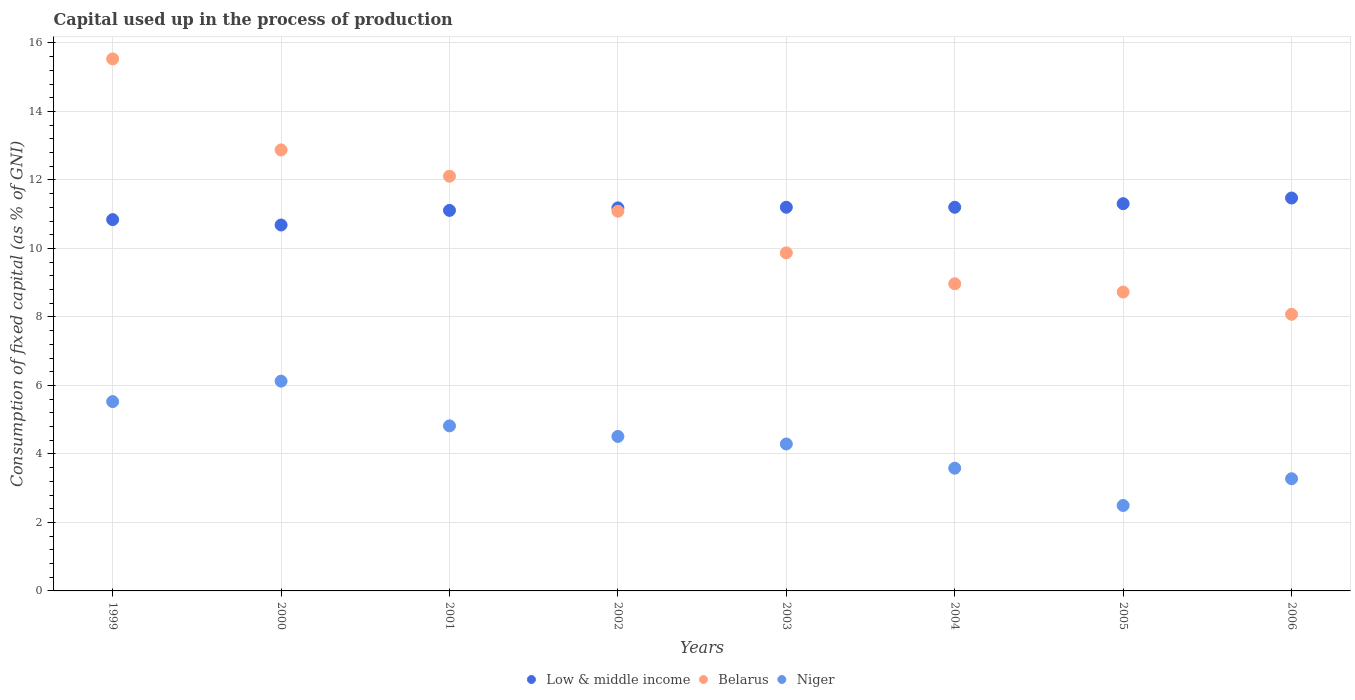What is the capital used up in the process of production in Belarus in 2005?
Your answer should be very brief. 8.73. Across all years, what is the maximum capital used up in the process of production in Niger?
Provide a succinct answer. 6.13. Across all years, what is the minimum capital used up in the process of production in Belarus?
Offer a terse response. 8.08. In which year was the capital used up in the process of production in Low & middle income maximum?
Offer a terse response. 2006. In which year was the capital used up in the process of production in Low & middle income minimum?
Provide a succinct answer. 2000. What is the total capital used up in the process of production in Low & middle income in the graph?
Your answer should be very brief. 89. What is the difference between the capital used up in the process of production in Belarus in 1999 and that in 2003?
Your answer should be compact. 5.66. What is the difference between the capital used up in the process of production in Low & middle income in 2003 and the capital used up in the process of production in Niger in 2005?
Provide a succinct answer. 8.71. What is the average capital used up in the process of production in Low & middle income per year?
Offer a terse response. 11.13. In the year 2003, what is the difference between the capital used up in the process of production in Belarus and capital used up in the process of production in Low & middle income?
Keep it short and to the point. -1.33. In how many years, is the capital used up in the process of production in Low & middle income greater than 12 %?
Ensure brevity in your answer.  0. What is the ratio of the capital used up in the process of production in Low & middle income in 1999 to that in 2005?
Provide a short and direct response. 0.96. Is the capital used up in the process of production in Low & middle income in 2003 less than that in 2006?
Give a very brief answer. Yes. What is the difference between the highest and the second highest capital used up in the process of production in Low & middle income?
Give a very brief answer. 0.17. What is the difference between the highest and the lowest capital used up in the process of production in Low & middle income?
Offer a terse response. 0.79. Is it the case that in every year, the sum of the capital used up in the process of production in Belarus and capital used up in the process of production in Niger  is greater than the capital used up in the process of production in Low & middle income?
Your response must be concise. No. Is the capital used up in the process of production in Niger strictly less than the capital used up in the process of production in Belarus over the years?
Give a very brief answer. Yes. How many years are there in the graph?
Ensure brevity in your answer.  8. What is the difference between two consecutive major ticks on the Y-axis?
Your response must be concise. 2. Are the values on the major ticks of Y-axis written in scientific E-notation?
Make the answer very short. No. Does the graph contain any zero values?
Provide a succinct answer. No. What is the title of the graph?
Your answer should be very brief. Capital used up in the process of production. What is the label or title of the Y-axis?
Offer a very short reply. Consumption of fixed capital (as % of GNI). What is the Consumption of fixed capital (as % of GNI) of Low & middle income in 1999?
Your answer should be very brief. 10.84. What is the Consumption of fixed capital (as % of GNI) of Belarus in 1999?
Offer a terse response. 15.53. What is the Consumption of fixed capital (as % of GNI) in Niger in 1999?
Offer a terse response. 5.53. What is the Consumption of fixed capital (as % of GNI) of Low & middle income in 2000?
Offer a very short reply. 10.68. What is the Consumption of fixed capital (as % of GNI) of Belarus in 2000?
Your response must be concise. 12.88. What is the Consumption of fixed capital (as % of GNI) in Niger in 2000?
Your answer should be compact. 6.13. What is the Consumption of fixed capital (as % of GNI) of Low & middle income in 2001?
Give a very brief answer. 11.11. What is the Consumption of fixed capital (as % of GNI) of Belarus in 2001?
Give a very brief answer. 12.11. What is the Consumption of fixed capital (as % of GNI) in Niger in 2001?
Your response must be concise. 4.82. What is the Consumption of fixed capital (as % of GNI) in Low & middle income in 2002?
Ensure brevity in your answer.  11.18. What is the Consumption of fixed capital (as % of GNI) in Belarus in 2002?
Your response must be concise. 11.09. What is the Consumption of fixed capital (as % of GNI) in Niger in 2002?
Provide a short and direct response. 4.51. What is the Consumption of fixed capital (as % of GNI) in Low & middle income in 2003?
Give a very brief answer. 11.2. What is the Consumption of fixed capital (as % of GNI) of Belarus in 2003?
Give a very brief answer. 9.87. What is the Consumption of fixed capital (as % of GNI) in Niger in 2003?
Provide a short and direct response. 4.29. What is the Consumption of fixed capital (as % of GNI) in Low & middle income in 2004?
Your answer should be very brief. 11.2. What is the Consumption of fixed capital (as % of GNI) of Belarus in 2004?
Make the answer very short. 8.97. What is the Consumption of fixed capital (as % of GNI) of Niger in 2004?
Keep it short and to the point. 3.58. What is the Consumption of fixed capital (as % of GNI) of Low & middle income in 2005?
Offer a very short reply. 11.31. What is the Consumption of fixed capital (as % of GNI) of Belarus in 2005?
Give a very brief answer. 8.73. What is the Consumption of fixed capital (as % of GNI) in Niger in 2005?
Offer a terse response. 2.49. What is the Consumption of fixed capital (as % of GNI) in Low & middle income in 2006?
Offer a terse response. 11.47. What is the Consumption of fixed capital (as % of GNI) of Belarus in 2006?
Offer a terse response. 8.08. What is the Consumption of fixed capital (as % of GNI) of Niger in 2006?
Ensure brevity in your answer.  3.28. Across all years, what is the maximum Consumption of fixed capital (as % of GNI) in Low & middle income?
Offer a terse response. 11.47. Across all years, what is the maximum Consumption of fixed capital (as % of GNI) in Belarus?
Your answer should be compact. 15.53. Across all years, what is the maximum Consumption of fixed capital (as % of GNI) of Niger?
Offer a terse response. 6.13. Across all years, what is the minimum Consumption of fixed capital (as % of GNI) of Low & middle income?
Your response must be concise. 10.68. Across all years, what is the minimum Consumption of fixed capital (as % of GNI) of Belarus?
Your response must be concise. 8.08. Across all years, what is the minimum Consumption of fixed capital (as % of GNI) of Niger?
Your response must be concise. 2.49. What is the total Consumption of fixed capital (as % of GNI) of Low & middle income in the graph?
Provide a succinct answer. 89. What is the total Consumption of fixed capital (as % of GNI) in Belarus in the graph?
Give a very brief answer. 87.25. What is the total Consumption of fixed capital (as % of GNI) of Niger in the graph?
Keep it short and to the point. 34.63. What is the difference between the Consumption of fixed capital (as % of GNI) in Low & middle income in 1999 and that in 2000?
Your response must be concise. 0.16. What is the difference between the Consumption of fixed capital (as % of GNI) in Belarus in 1999 and that in 2000?
Keep it short and to the point. 2.66. What is the difference between the Consumption of fixed capital (as % of GNI) of Niger in 1999 and that in 2000?
Offer a very short reply. -0.6. What is the difference between the Consumption of fixed capital (as % of GNI) of Low & middle income in 1999 and that in 2001?
Offer a very short reply. -0.27. What is the difference between the Consumption of fixed capital (as % of GNI) in Belarus in 1999 and that in 2001?
Keep it short and to the point. 3.42. What is the difference between the Consumption of fixed capital (as % of GNI) in Niger in 1999 and that in 2001?
Keep it short and to the point. 0.71. What is the difference between the Consumption of fixed capital (as % of GNI) in Low & middle income in 1999 and that in 2002?
Offer a terse response. -0.34. What is the difference between the Consumption of fixed capital (as % of GNI) of Belarus in 1999 and that in 2002?
Offer a terse response. 4.45. What is the difference between the Consumption of fixed capital (as % of GNI) of Niger in 1999 and that in 2002?
Ensure brevity in your answer.  1.02. What is the difference between the Consumption of fixed capital (as % of GNI) of Low & middle income in 1999 and that in 2003?
Offer a very short reply. -0.36. What is the difference between the Consumption of fixed capital (as % of GNI) in Belarus in 1999 and that in 2003?
Give a very brief answer. 5.66. What is the difference between the Consumption of fixed capital (as % of GNI) in Niger in 1999 and that in 2003?
Offer a very short reply. 1.24. What is the difference between the Consumption of fixed capital (as % of GNI) in Low & middle income in 1999 and that in 2004?
Keep it short and to the point. -0.36. What is the difference between the Consumption of fixed capital (as % of GNI) of Belarus in 1999 and that in 2004?
Ensure brevity in your answer.  6.57. What is the difference between the Consumption of fixed capital (as % of GNI) in Niger in 1999 and that in 2004?
Provide a short and direct response. 1.94. What is the difference between the Consumption of fixed capital (as % of GNI) of Low & middle income in 1999 and that in 2005?
Your answer should be compact. -0.47. What is the difference between the Consumption of fixed capital (as % of GNI) of Belarus in 1999 and that in 2005?
Provide a short and direct response. 6.81. What is the difference between the Consumption of fixed capital (as % of GNI) of Niger in 1999 and that in 2005?
Offer a very short reply. 3.03. What is the difference between the Consumption of fixed capital (as % of GNI) in Low & middle income in 1999 and that in 2006?
Offer a very short reply. -0.63. What is the difference between the Consumption of fixed capital (as % of GNI) in Belarus in 1999 and that in 2006?
Your answer should be compact. 7.46. What is the difference between the Consumption of fixed capital (as % of GNI) in Niger in 1999 and that in 2006?
Offer a terse response. 2.25. What is the difference between the Consumption of fixed capital (as % of GNI) of Low & middle income in 2000 and that in 2001?
Offer a very short reply. -0.43. What is the difference between the Consumption of fixed capital (as % of GNI) in Belarus in 2000 and that in 2001?
Provide a short and direct response. 0.77. What is the difference between the Consumption of fixed capital (as % of GNI) of Niger in 2000 and that in 2001?
Offer a terse response. 1.31. What is the difference between the Consumption of fixed capital (as % of GNI) of Low & middle income in 2000 and that in 2002?
Offer a terse response. -0.5. What is the difference between the Consumption of fixed capital (as % of GNI) in Belarus in 2000 and that in 2002?
Ensure brevity in your answer.  1.79. What is the difference between the Consumption of fixed capital (as % of GNI) in Niger in 2000 and that in 2002?
Your answer should be compact. 1.61. What is the difference between the Consumption of fixed capital (as % of GNI) of Low & middle income in 2000 and that in 2003?
Provide a short and direct response. -0.52. What is the difference between the Consumption of fixed capital (as % of GNI) of Belarus in 2000 and that in 2003?
Offer a terse response. 3.01. What is the difference between the Consumption of fixed capital (as % of GNI) in Niger in 2000 and that in 2003?
Offer a very short reply. 1.83. What is the difference between the Consumption of fixed capital (as % of GNI) in Low & middle income in 2000 and that in 2004?
Ensure brevity in your answer.  -0.52. What is the difference between the Consumption of fixed capital (as % of GNI) of Belarus in 2000 and that in 2004?
Your answer should be compact. 3.91. What is the difference between the Consumption of fixed capital (as % of GNI) of Niger in 2000 and that in 2004?
Keep it short and to the point. 2.54. What is the difference between the Consumption of fixed capital (as % of GNI) of Low & middle income in 2000 and that in 2005?
Keep it short and to the point. -0.62. What is the difference between the Consumption of fixed capital (as % of GNI) in Belarus in 2000 and that in 2005?
Offer a terse response. 4.15. What is the difference between the Consumption of fixed capital (as % of GNI) in Niger in 2000 and that in 2005?
Provide a short and direct response. 3.63. What is the difference between the Consumption of fixed capital (as % of GNI) of Low & middle income in 2000 and that in 2006?
Keep it short and to the point. -0.79. What is the difference between the Consumption of fixed capital (as % of GNI) in Belarus in 2000 and that in 2006?
Provide a short and direct response. 4.8. What is the difference between the Consumption of fixed capital (as % of GNI) in Niger in 2000 and that in 2006?
Offer a very short reply. 2.85. What is the difference between the Consumption of fixed capital (as % of GNI) in Low & middle income in 2001 and that in 2002?
Your answer should be compact. -0.07. What is the difference between the Consumption of fixed capital (as % of GNI) of Belarus in 2001 and that in 2002?
Your answer should be compact. 1.02. What is the difference between the Consumption of fixed capital (as % of GNI) of Niger in 2001 and that in 2002?
Keep it short and to the point. 0.31. What is the difference between the Consumption of fixed capital (as % of GNI) in Low & middle income in 2001 and that in 2003?
Your answer should be very brief. -0.09. What is the difference between the Consumption of fixed capital (as % of GNI) in Belarus in 2001 and that in 2003?
Offer a very short reply. 2.24. What is the difference between the Consumption of fixed capital (as % of GNI) in Niger in 2001 and that in 2003?
Your answer should be compact. 0.53. What is the difference between the Consumption of fixed capital (as % of GNI) of Low & middle income in 2001 and that in 2004?
Your response must be concise. -0.09. What is the difference between the Consumption of fixed capital (as % of GNI) of Belarus in 2001 and that in 2004?
Your answer should be compact. 3.14. What is the difference between the Consumption of fixed capital (as % of GNI) of Niger in 2001 and that in 2004?
Provide a short and direct response. 1.24. What is the difference between the Consumption of fixed capital (as % of GNI) in Low & middle income in 2001 and that in 2005?
Offer a very short reply. -0.2. What is the difference between the Consumption of fixed capital (as % of GNI) in Belarus in 2001 and that in 2005?
Provide a short and direct response. 3.38. What is the difference between the Consumption of fixed capital (as % of GNI) of Niger in 2001 and that in 2005?
Keep it short and to the point. 2.32. What is the difference between the Consumption of fixed capital (as % of GNI) of Low & middle income in 2001 and that in 2006?
Your response must be concise. -0.36. What is the difference between the Consumption of fixed capital (as % of GNI) in Belarus in 2001 and that in 2006?
Provide a succinct answer. 4.03. What is the difference between the Consumption of fixed capital (as % of GNI) of Niger in 2001 and that in 2006?
Offer a very short reply. 1.54. What is the difference between the Consumption of fixed capital (as % of GNI) in Low & middle income in 2002 and that in 2003?
Your response must be concise. -0.02. What is the difference between the Consumption of fixed capital (as % of GNI) of Belarus in 2002 and that in 2003?
Give a very brief answer. 1.22. What is the difference between the Consumption of fixed capital (as % of GNI) in Niger in 2002 and that in 2003?
Provide a succinct answer. 0.22. What is the difference between the Consumption of fixed capital (as % of GNI) in Low & middle income in 2002 and that in 2004?
Ensure brevity in your answer.  -0.02. What is the difference between the Consumption of fixed capital (as % of GNI) in Belarus in 2002 and that in 2004?
Give a very brief answer. 2.12. What is the difference between the Consumption of fixed capital (as % of GNI) in Niger in 2002 and that in 2004?
Keep it short and to the point. 0.93. What is the difference between the Consumption of fixed capital (as % of GNI) in Low & middle income in 2002 and that in 2005?
Offer a terse response. -0.12. What is the difference between the Consumption of fixed capital (as % of GNI) of Belarus in 2002 and that in 2005?
Provide a succinct answer. 2.36. What is the difference between the Consumption of fixed capital (as % of GNI) in Niger in 2002 and that in 2005?
Your response must be concise. 2.02. What is the difference between the Consumption of fixed capital (as % of GNI) of Low & middle income in 2002 and that in 2006?
Ensure brevity in your answer.  -0.29. What is the difference between the Consumption of fixed capital (as % of GNI) of Belarus in 2002 and that in 2006?
Ensure brevity in your answer.  3.01. What is the difference between the Consumption of fixed capital (as % of GNI) of Niger in 2002 and that in 2006?
Make the answer very short. 1.24. What is the difference between the Consumption of fixed capital (as % of GNI) in Low & middle income in 2003 and that in 2004?
Provide a succinct answer. 0. What is the difference between the Consumption of fixed capital (as % of GNI) of Belarus in 2003 and that in 2004?
Offer a terse response. 0.9. What is the difference between the Consumption of fixed capital (as % of GNI) of Niger in 2003 and that in 2004?
Keep it short and to the point. 0.71. What is the difference between the Consumption of fixed capital (as % of GNI) in Low & middle income in 2003 and that in 2005?
Offer a very short reply. -0.1. What is the difference between the Consumption of fixed capital (as % of GNI) in Belarus in 2003 and that in 2005?
Keep it short and to the point. 1.14. What is the difference between the Consumption of fixed capital (as % of GNI) of Niger in 2003 and that in 2005?
Offer a terse response. 1.8. What is the difference between the Consumption of fixed capital (as % of GNI) in Low & middle income in 2003 and that in 2006?
Keep it short and to the point. -0.27. What is the difference between the Consumption of fixed capital (as % of GNI) of Belarus in 2003 and that in 2006?
Your answer should be compact. 1.79. What is the difference between the Consumption of fixed capital (as % of GNI) of Niger in 2003 and that in 2006?
Your response must be concise. 1.02. What is the difference between the Consumption of fixed capital (as % of GNI) of Low & middle income in 2004 and that in 2005?
Keep it short and to the point. -0.1. What is the difference between the Consumption of fixed capital (as % of GNI) of Belarus in 2004 and that in 2005?
Your answer should be compact. 0.24. What is the difference between the Consumption of fixed capital (as % of GNI) in Niger in 2004 and that in 2005?
Provide a short and direct response. 1.09. What is the difference between the Consumption of fixed capital (as % of GNI) of Low & middle income in 2004 and that in 2006?
Give a very brief answer. -0.27. What is the difference between the Consumption of fixed capital (as % of GNI) of Belarus in 2004 and that in 2006?
Your answer should be compact. 0.89. What is the difference between the Consumption of fixed capital (as % of GNI) in Niger in 2004 and that in 2006?
Provide a short and direct response. 0.31. What is the difference between the Consumption of fixed capital (as % of GNI) in Low & middle income in 2005 and that in 2006?
Keep it short and to the point. -0.17. What is the difference between the Consumption of fixed capital (as % of GNI) of Belarus in 2005 and that in 2006?
Keep it short and to the point. 0.65. What is the difference between the Consumption of fixed capital (as % of GNI) of Niger in 2005 and that in 2006?
Make the answer very short. -0.78. What is the difference between the Consumption of fixed capital (as % of GNI) of Low & middle income in 1999 and the Consumption of fixed capital (as % of GNI) of Belarus in 2000?
Offer a very short reply. -2.03. What is the difference between the Consumption of fixed capital (as % of GNI) in Low & middle income in 1999 and the Consumption of fixed capital (as % of GNI) in Niger in 2000?
Your answer should be compact. 4.72. What is the difference between the Consumption of fixed capital (as % of GNI) of Belarus in 1999 and the Consumption of fixed capital (as % of GNI) of Niger in 2000?
Your answer should be very brief. 9.41. What is the difference between the Consumption of fixed capital (as % of GNI) in Low & middle income in 1999 and the Consumption of fixed capital (as % of GNI) in Belarus in 2001?
Ensure brevity in your answer.  -1.27. What is the difference between the Consumption of fixed capital (as % of GNI) of Low & middle income in 1999 and the Consumption of fixed capital (as % of GNI) of Niger in 2001?
Make the answer very short. 6.02. What is the difference between the Consumption of fixed capital (as % of GNI) in Belarus in 1999 and the Consumption of fixed capital (as % of GNI) in Niger in 2001?
Give a very brief answer. 10.71. What is the difference between the Consumption of fixed capital (as % of GNI) in Low & middle income in 1999 and the Consumption of fixed capital (as % of GNI) in Belarus in 2002?
Offer a terse response. -0.24. What is the difference between the Consumption of fixed capital (as % of GNI) in Low & middle income in 1999 and the Consumption of fixed capital (as % of GNI) in Niger in 2002?
Ensure brevity in your answer.  6.33. What is the difference between the Consumption of fixed capital (as % of GNI) in Belarus in 1999 and the Consumption of fixed capital (as % of GNI) in Niger in 2002?
Give a very brief answer. 11.02. What is the difference between the Consumption of fixed capital (as % of GNI) of Low & middle income in 1999 and the Consumption of fixed capital (as % of GNI) of Niger in 2003?
Your answer should be very brief. 6.55. What is the difference between the Consumption of fixed capital (as % of GNI) in Belarus in 1999 and the Consumption of fixed capital (as % of GNI) in Niger in 2003?
Your response must be concise. 11.24. What is the difference between the Consumption of fixed capital (as % of GNI) of Low & middle income in 1999 and the Consumption of fixed capital (as % of GNI) of Belarus in 2004?
Your answer should be compact. 1.87. What is the difference between the Consumption of fixed capital (as % of GNI) of Low & middle income in 1999 and the Consumption of fixed capital (as % of GNI) of Niger in 2004?
Offer a very short reply. 7.26. What is the difference between the Consumption of fixed capital (as % of GNI) of Belarus in 1999 and the Consumption of fixed capital (as % of GNI) of Niger in 2004?
Make the answer very short. 11.95. What is the difference between the Consumption of fixed capital (as % of GNI) of Low & middle income in 1999 and the Consumption of fixed capital (as % of GNI) of Belarus in 2005?
Keep it short and to the point. 2.11. What is the difference between the Consumption of fixed capital (as % of GNI) in Low & middle income in 1999 and the Consumption of fixed capital (as % of GNI) in Niger in 2005?
Keep it short and to the point. 8.35. What is the difference between the Consumption of fixed capital (as % of GNI) in Belarus in 1999 and the Consumption of fixed capital (as % of GNI) in Niger in 2005?
Offer a terse response. 13.04. What is the difference between the Consumption of fixed capital (as % of GNI) of Low & middle income in 1999 and the Consumption of fixed capital (as % of GNI) of Belarus in 2006?
Ensure brevity in your answer.  2.76. What is the difference between the Consumption of fixed capital (as % of GNI) of Low & middle income in 1999 and the Consumption of fixed capital (as % of GNI) of Niger in 2006?
Keep it short and to the point. 7.57. What is the difference between the Consumption of fixed capital (as % of GNI) of Belarus in 1999 and the Consumption of fixed capital (as % of GNI) of Niger in 2006?
Make the answer very short. 12.26. What is the difference between the Consumption of fixed capital (as % of GNI) in Low & middle income in 2000 and the Consumption of fixed capital (as % of GNI) in Belarus in 2001?
Offer a very short reply. -1.43. What is the difference between the Consumption of fixed capital (as % of GNI) in Low & middle income in 2000 and the Consumption of fixed capital (as % of GNI) in Niger in 2001?
Your answer should be compact. 5.87. What is the difference between the Consumption of fixed capital (as % of GNI) in Belarus in 2000 and the Consumption of fixed capital (as % of GNI) in Niger in 2001?
Give a very brief answer. 8.06. What is the difference between the Consumption of fixed capital (as % of GNI) in Low & middle income in 2000 and the Consumption of fixed capital (as % of GNI) in Belarus in 2002?
Ensure brevity in your answer.  -0.4. What is the difference between the Consumption of fixed capital (as % of GNI) in Low & middle income in 2000 and the Consumption of fixed capital (as % of GNI) in Niger in 2002?
Your response must be concise. 6.17. What is the difference between the Consumption of fixed capital (as % of GNI) of Belarus in 2000 and the Consumption of fixed capital (as % of GNI) of Niger in 2002?
Provide a succinct answer. 8.37. What is the difference between the Consumption of fixed capital (as % of GNI) in Low & middle income in 2000 and the Consumption of fixed capital (as % of GNI) in Belarus in 2003?
Keep it short and to the point. 0.81. What is the difference between the Consumption of fixed capital (as % of GNI) in Low & middle income in 2000 and the Consumption of fixed capital (as % of GNI) in Niger in 2003?
Give a very brief answer. 6.39. What is the difference between the Consumption of fixed capital (as % of GNI) in Belarus in 2000 and the Consumption of fixed capital (as % of GNI) in Niger in 2003?
Provide a succinct answer. 8.59. What is the difference between the Consumption of fixed capital (as % of GNI) of Low & middle income in 2000 and the Consumption of fixed capital (as % of GNI) of Belarus in 2004?
Provide a succinct answer. 1.72. What is the difference between the Consumption of fixed capital (as % of GNI) in Low & middle income in 2000 and the Consumption of fixed capital (as % of GNI) in Niger in 2004?
Keep it short and to the point. 7.1. What is the difference between the Consumption of fixed capital (as % of GNI) of Belarus in 2000 and the Consumption of fixed capital (as % of GNI) of Niger in 2004?
Keep it short and to the point. 9.29. What is the difference between the Consumption of fixed capital (as % of GNI) of Low & middle income in 2000 and the Consumption of fixed capital (as % of GNI) of Belarus in 2005?
Provide a succinct answer. 1.96. What is the difference between the Consumption of fixed capital (as % of GNI) of Low & middle income in 2000 and the Consumption of fixed capital (as % of GNI) of Niger in 2005?
Ensure brevity in your answer.  8.19. What is the difference between the Consumption of fixed capital (as % of GNI) in Belarus in 2000 and the Consumption of fixed capital (as % of GNI) in Niger in 2005?
Ensure brevity in your answer.  10.38. What is the difference between the Consumption of fixed capital (as % of GNI) in Low & middle income in 2000 and the Consumption of fixed capital (as % of GNI) in Belarus in 2006?
Keep it short and to the point. 2.61. What is the difference between the Consumption of fixed capital (as % of GNI) of Low & middle income in 2000 and the Consumption of fixed capital (as % of GNI) of Niger in 2006?
Keep it short and to the point. 7.41. What is the difference between the Consumption of fixed capital (as % of GNI) of Belarus in 2000 and the Consumption of fixed capital (as % of GNI) of Niger in 2006?
Keep it short and to the point. 9.6. What is the difference between the Consumption of fixed capital (as % of GNI) of Low & middle income in 2001 and the Consumption of fixed capital (as % of GNI) of Belarus in 2002?
Your answer should be very brief. 0.02. What is the difference between the Consumption of fixed capital (as % of GNI) of Low & middle income in 2001 and the Consumption of fixed capital (as % of GNI) of Niger in 2002?
Provide a succinct answer. 6.6. What is the difference between the Consumption of fixed capital (as % of GNI) of Belarus in 2001 and the Consumption of fixed capital (as % of GNI) of Niger in 2002?
Ensure brevity in your answer.  7.6. What is the difference between the Consumption of fixed capital (as % of GNI) of Low & middle income in 2001 and the Consumption of fixed capital (as % of GNI) of Belarus in 2003?
Offer a terse response. 1.24. What is the difference between the Consumption of fixed capital (as % of GNI) in Low & middle income in 2001 and the Consumption of fixed capital (as % of GNI) in Niger in 2003?
Offer a terse response. 6.82. What is the difference between the Consumption of fixed capital (as % of GNI) in Belarus in 2001 and the Consumption of fixed capital (as % of GNI) in Niger in 2003?
Offer a very short reply. 7.82. What is the difference between the Consumption of fixed capital (as % of GNI) of Low & middle income in 2001 and the Consumption of fixed capital (as % of GNI) of Belarus in 2004?
Ensure brevity in your answer.  2.14. What is the difference between the Consumption of fixed capital (as % of GNI) in Low & middle income in 2001 and the Consumption of fixed capital (as % of GNI) in Niger in 2004?
Keep it short and to the point. 7.53. What is the difference between the Consumption of fixed capital (as % of GNI) in Belarus in 2001 and the Consumption of fixed capital (as % of GNI) in Niger in 2004?
Offer a very short reply. 8.53. What is the difference between the Consumption of fixed capital (as % of GNI) in Low & middle income in 2001 and the Consumption of fixed capital (as % of GNI) in Belarus in 2005?
Give a very brief answer. 2.38. What is the difference between the Consumption of fixed capital (as % of GNI) of Low & middle income in 2001 and the Consumption of fixed capital (as % of GNI) of Niger in 2005?
Ensure brevity in your answer.  8.62. What is the difference between the Consumption of fixed capital (as % of GNI) of Belarus in 2001 and the Consumption of fixed capital (as % of GNI) of Niger in 2005?
Your response must be concise. 9.61. What is the difference between the Consumption of fixed capital (as % of GNI) of Low & middle income in 2001 and the Consumption of fixed capital (as % of GNI) of Belarus in 2006?
Provide a short and direct response. 3.03. What is the difference between the Consumption of fixed capital (as % of GNI) of Low & middle income in 2001 and the Consumption of fixed capital (as % of GNI) of Niger in 2006?
Your response must be concise. 7.84. What is the difference between the Consumption of fixed capital (as % of GNI) of Belarus in 2001 and the Consumption of fixed capital (as % of GNI) of Niger in 2006?
Provide a succinct answer. 8.83. What is the difference between the Consumption of fixed capital (as % of GNI) in Low & middle income in 2002 and the Consumption of fixed capital (as % of GNI) in Belarus in 2003?
Keep it short and to the point. 1.31. What is the difference between the Consumption of fixed capital (as % of GNI) in Low & middle income in 2002 and the Consumption of fixed capital (as % of GNI) in Niger in 2003?
Your answer should be very brief. 6.89. What is the difference between the Consumption of fixed capital (as % of GNI) of Belarus in 2002 and the Consumption of fixed capital (as % of GNI) of Niger in 2003?
Your answer should be compact. 6.8. What is the difference between the Consumption of fixed capital (as % of GNI) of Low & middle income in 2002 and the Consumption of fixed capital (as % of GNI) of Belarus in 2004?
Offer a terse response. 2.22. What is the difference between the Consumption of fixed capital (as % of GNI) in Low & middle income in 2002 and the Consumption of fixed capital (as % of GNI) in Niger in 2004?
Your response must be concise. 7.6. What is the difference between the Consumption of fixed capital (as % of GNI) in Belarus in 2002 and the Consumption of fixed capital (as % of GNI) in Niger in 2004?
Provide a succinct answer. 7.5. What is the difference between the Consumption of fixed capital (as % of GNI) of Low & middle income in 2002 and the Consumption of fixed capital (as % of GNI) of Belarus in 2005?
Offer a very short reply. 2.46. What is the difference between the Consumption of fixed capital (as % of GNI) of Low & middle income in 2002 and the Consumption of fixed capital (as % of GNI) of Niger in 2005?
Keep it short and to the point. 8.69. What is the difference between the Consumption of fixed capital (as % of GNI) in Belarus in 2002 and the Consumption of fixed capital (as % of GNI) in Niger in 2005?
Offer a terse response. 8.59. What is the difference between the Consumption of fixed capital (as % of GNI) in Low & middle income in 2002 and the Consumption of fixed capital (as % of GNI) in Belarus in 2006?
Offer a terse response. 3.11. What is the difference between the Consumption of fixed capital (as % of GNI) of Low & middle income in 2002 and the Consumption of fixed capital (as % of GNI) of Niger in 2006?
Offer a very short reply. 7.91. What is the difference between the Consumption of fixed capital (as % of GNI) in Belarus in 2002 and the Consumption of fixed capital (as % of GNI) in Niger in 2006?
Ensure brevity in your answer.  7.81. What is the difference between the Consumption of fixed capital (as % of GNI) of Low & middle income in 2003 and the Consumption of fixed capital (as % of GNI) of Belarus in 2004?
Your answer should be very brief. 2.23. What is the difference between the Consumption of fixed capital (as % of GNI) of Low & middle income in 2003 and the Consumption of fixed capital (as % of GNI) of Niger in 2004?
Make the answer very short. 7.62. What is the difference between the Consumption of fixed capital (as % of GNI) of Belarus in 2003 and the Consumption of fixed capital (as % of GNI) of Niger in 2004?
Make the answer very short. 6.29. What is the difference between the Consumption of fixed capital (as % of GNI) of Low & middle income in 2003 and the Consumption of fixed capital (as % of GNI) of Belarus in 2005?
Make the answer very short. 2.48. What is the difference between the Consumption of fixed capital (as % of GNI) in Low & middle income in 2003 and the Consumption of fixed capital (as % of GNI) in Niger in 2005?
Your answer should be compact. 8.71. What is the difference between the Consumption of fixed capital (as % of GNI) of Belarus in 2003 and the Consumption of fixed capital (as % of GNI) of Niger in 2005?
Ensure brevity in your answer.  7.38. What is the difference between the Consumption of fixed capital (as % of GNI) of Low & middle income in 2003 and the Consumption of fixed capital (as % of GNI) of Belarus in 2006?
Give a very brief answer. 3.13. What is the difference between the Consumption of fixed capital (as % of GNI) of Low & middle income in 2003 and the Consumption of fixed capital (as % of GNI) of Niger in 2006?
Ensure brevity in your answer.  7.93. What is the difference between the Consumption of fixed capital (as % of GNI) in Belarus in 2003 and the Consumption of fixed capital (as % of GNI) in Niger in 2006?
Give a very brief answer. 6.59. What is the difference between the Consumption of fixed capital (as % of GNI) of Low & middle income in 2004 and the Consumption of fixed capital (as % of GNI) of Belarus in 2005?
Provide a short and direct response. 2.48. What is the difference between the Consumption of fixed capital (as % of GNI) of Low & middle income in 2004 and the Consumption of fixed capital (as % of GNI) of Niger in 2005?
Provide a succinct answer. 8.71. What is the difference between the Consumption of fixed capital (as % of GNI) of Belarus in 2004 and the Consumption of fixed capital (as % of GNI) of Niger in 2005?
Your answer should be compact. 6.47. What is the difference between the Consumption of fixed capital (as % of GNI) of Low & middle income in 2004 and the Consumption of fixed capital (as % of GNI) of Belarus in 2006?
Your answer should be compact. 3.12. What is the difference between the Consumption of fixed capital (as % of GNI) in Low & middle income in 2004 and the Consumption of fixed capital (as % of GNI) in Niger in 2006?
Keep it short and to the point. 7.93. What is the difference between the Consumption of fixed capital (as % of GNI) of Belarus in 2004 and the Consumption of fixed capital (as % of GNI) of Niger in 2006?
Provide a succinct answer. 5.69. What is the difference between the Consumption of fixed capital (as % of GNI) in Low & middle income in 2005 and the Consumption of fixed capital (as % of GNI) in Belarus in 2006?
Ensure brevity in your answer.  3.23. What is the difference between the Consumption of fixed capital (as % of GNI) in Low & middle income in 2005 and the Consumption of fixed capital (as % of GNI) in Niger in 2006?
Your response must be concise. 8.03. What is the difference between the Consumption of fixed capital (as % of GNI) of Belarus in 2005 and the Consumption of fixed capital (as % of GNI) of Niger in 2006?
Provide a succinct answer. 5.45. What is the average Consumption of fixed capital (as % of GNI) in Low & middle income per year?
Give a very brief answer. 11.13. What is the average Consumption of fixed capital (as % of GNI) of Belarus per year?
Offer a terse response. 10.91. What is the average Consumption of fixed capital (as % of GNI) in Niger per year?
Keep it short and to the point. 4.33. In the year 1999, what is the difference between the Consumption of fixed capital (as % of GNI) of Low & middle income and Consumption of fixed capital (as % of GNI) of Belarus?
Your answer should be very brief. -4.69. In the year 1999, what is the difference between the Consumption of fixed capital (as % of GNI) in Low & middle income and Consumption of fixed capital (as % of GNI) in Niger?
Provide a short and direct response. 5.31. In the year 1999, what is the difference between the Consumption of fixed capital (as % of GNI) of Belarus and Consumption of fixed capital (as % of GNI) of Niger?
Your answer should be very brief. 10.01. In the year 2000, what is the difference between the Consumption of fixed capital (as % of GNI) of Low & middle income and Consumption of fixed capital (as % of GNI) of Belarus?
Ensure brevity in your answer.  -2.19. In the year 2000, what is the difference between the Consumption of fixed capital (as % of GNI) of Low & middle income and Consumption of fixed capital (as % of GNI) of Niger?
Ensure brevity in your answer.  4.56. In the year 2000, what is the difference between the Consumption of fixed capital (as % of GNI) in Belarus and Consumption of fixed capital (as % of GNI) in Niger?
Give a very brief answer. 6.75. In the year 2001, what is the difference between the Consumption of fixed capital (as % of GNI) of Low & middle income and Consumption of fixed capital (as % of GNI) of Belarus?
Provide a short and direct response. -1. In the year 2001, what is the difference between the Consumption of fixed capital (as % of GNI) in Low & middle income and Consumption of fixed capital (as % of GNI) in Niger?
Provide a short and direct response. 6.29. In the year 2001, what is the difference between the Consumption of fixed capital (as % of GNI) of Belarus and Consumption of fixed capital (as % of GNI) of Niger?
Your answer should be very brief. 7.29. In the year 2002, what is the difference between the Consumption of fixed capital (as % of GNI) of Low & middle income and Consumption of fixed capital (as % of GNI) of Belarus?
Ensure brevity in your answer.  0.1. In the year 2002, what is the difference between the Consumption of fixed capital (as % of GNI) of Low & middle income and Consumption of fixed capital (as % of GNI) of Niger?
Your answer should be compact. 6.67. In the year 2002, what is the difference between the Consumption of fixed capital (as % of GNI) in Belarus and Consumption of fixed capital (as % of GNI) in Niger?
Keep it short and to the point. 6.58. In the year 2003, what is the difference between the Consumption of fixed capital (as % of GNI) in Low & middle income and Consumption of fixed capital (as % of GNI) in Belarus?
Your response must be concise. 1.33. In the year 2003, what is the difference between the Consumption of fixed capital (as % of GNI) in Low & middle income and Consumption of fixed capital (as % of GNI) in Niger?
Ensure brevity in your answer.  6.91. In the year 2003, what is the difference between the Consumption of fixed capital (as % of GNI) in Belarus and Consumption of fixed capital (as % of GNI) in Niger?
Keep it short and to the point. 5.58. In the year 2004, what is the difference between the Consumption of fixed capital (as % of GNI) in Low & middle income and Consumption of fixed capital (as % of GNI) in Belarus?
Offer a terse response. 2.23. In the year 2004, what is the difference between the Consumption of fixed capital (as % of GNI) of Low & middle income and Consumption of fixed capital (as % of GNI) of Niger?
Your response must be concise. 7.62. In the year 2004, what is the difference between the Consumption of fixed capital (as % of GNI) of Belarus and Consumption of fixed capital (as % of GNI) of Niger?
Ensure brevity in your answer.  5.39. In the year 2005, what is the difference between the Consumption of fixed capital (as % of GNI) in Low & middle income and Consumption of fixed capital (as % of GNI) in Belarus?
Ensure brevity in your answer.  2.58. In the year 2005, what is the difference between the Consumption of fixed capital (as % of GNI) of Low & middle income and Consumption of fixed capital (as % of GNI) of Niger?
Give a very brief answer. 8.81. In the year 2005, what is the difference between the Consumption of fixed capital (as % of GNI) of Belarus and Consumption of fixed capital (as % of GNI) of Niger?
Provide a succinct answer. 6.23. In the year 2006, what is the difference between the Consumption of fixed capital (as % of GNI) in Low & middle income and Consumption of fixed capital (as % of GNI) in Belarus?
Your answer should be compact. 3.4. In the year 2006, what is the difference between the Consumption of fixed capital (as % of GNI) in Low & middle income and Consumption of fixed capital (as % of GNI) in Niger?
Your answer should be compact. 8.2. In the year 2006, what is the difference between the Consumption of fixed capital (as % of GNI) in Belarus and Consumption of fixed capital (as % of GNI) in Niger?
Provide a short and direct response. 4.8. What is the ratio of the Consumption of fixed capital (as % of GNI) of Low & middle income in 1999 to that in 2000?
Offer a terse response. 1.01. What is the ratio of the Consumption of fixed capital (as % of GNI) in Belarus in 1999 to that in 2000?
Provide a succinct answer. 1.21. What is the ratio of the Consumption of fixed capital (as % of GNI) of Niger in 1999 to that in 2000?
Give a very brief answer. 0.9. What is the ratio of the Consumption of fixed capital (as % of GNI) of Low & middle income in 1999 to that in 2001?
Keep it short and to the point. 0.98. What is the ratio of the Consumption of fixed capital (as % of GNI) of Belarus in 1999 to that in 2001?
Keep it short and to the point. 1.28. What is the ratio of the Consumption of fixed capital (as % of GNI) in Niger in 1999 to that in 2001?
Ensure brevity in your answer.  1.15. What is the ratio of the Consumption of fixed capital (as % of GNI) of Low & middle income in 1999 to that in 2002?
Provide a succinct answer. 0.97. What is the ratio of the Consumption of fixed capital (as % of GNI) of Belarus in 1999 to that in 2002?
Make the answer very short. 1.4. What is the ratio of the Consumption of fixed capital (as % of GNI) in Niger in 1999 to that in 2002?
Your response must be concise. 1.23. What is the ratio of the Consumption of fixed capital (as % of GNI) in Low & middle income in 1999 to that in 2003?
Keep it short and to the point. 0.97. What is the ratio of the Consumption of fixed capital (as % of GNI) in Belarus in 1999 to that in 2003?
Ensure brevity in your answer.  1.57. What is the ratio of the Consumption of fixed capital (as % of GNI) in Niger in 1999 to that in 2003?
Give a very brief answer. 1.29. What is the ratio of the Consumption of fixed capital (as % of GNI) of Low & middle income in 1999 to that in 2004?
Make the answer very short. 0.97. What is the ratio of the Consumption of fixed capital (as % of GNI) of Belarus in 1999 to that in 2004?
Offer a terse response. 1.73. What is the ratio of the Consumption of fixed capital (as % of GNI) in Niger in 1999 to that in 2004?
Provide a succinct answer. 1.54. What is the ratio of the Consumption of fixed capital (as % of GNI) of Low & middle income in 1999 to that in 2005?
Give a very brief answer. 0.96. What is the ratio of the Consumption of fixed capital (as % of GNI) in Belarus in 1999 to that in 2005?
Make the answer very short. 1.78. What is the ratio of the Consumption of fixed capital (as % of GNI) in Niger in 1999 to that in 2005?
Offer a very short reply. 2.22. What is the ratio of the Consumption of fixed capital (as % of GNI) of Low & middle income in 1999 to that in 2006?
Make the answer very short. 0.94. What is the ratio of the Consumption of fixed capital (as % of GNI) of Belarus in 1999 to that in 2006?
Your response must be concise. 1.92. What is the ratio of the Consumption of fixed capital (as % of GNI) in Niger in 1999 to that in 2006?
Keep it short and to the point. 1.69. What is the ratio of the Consumption of fixed capital (as % of GNI) of Low & middle income in 2000 to that in 2001?
Offer a very short reply. 0.96. What is the ratio of the Consumption of fixed capital (as % of GNI) of Belarus in 2000 to that in 2001?
Offer a terse response. 1.06. What is the ratio of the Consumption of fixed capital (as % of GNI) in Niger in 2000 to that in 2001?
Ensure brevity in your answer.  1.27. What is the ratio of the Consumption of fixed capital (as % of GNI) in Low & middle income in 2000 to that in 2002?
Ensure brevity in your answer.  0.96. What is the ratio of the Consumption of fixed capital (as % of GNI) in Belarus in 2000 to that in 2002?
Offer a very short reply. 1.16. What is the ratio of the Consumption of fixed capital (as % of GNI) of Niger in 2000 to that in 2002?
Make the answer very short. 1.36. What is the ratio of the Consumption of fixed capital (as % of GNI) in Low & middle income in 2000 to that in 2003?
Provide a succinct answer. 0.95. What is the ratio of the Consumption of fixed capital (as % of GNI) of Belarus in 2000 to that in 2003?
Provide a short and direct response. 1.3. What is the ratio of the Consumption of fixed capital (as % of GNI) of Niger in 2000 to that in 2003?
Keep it short and to the point. 1.43. What is the ratio of the Consumption of fixed capital (as % of GNI) of Low & middle income in 2000 to that in 2004?
Give a very brief answer. 0.95. What is the ratio of the Consumption of fixed capital (as % of GNI) in Belarus in 2000 to that in 2004?
Provide a succinct answer. 1.44. What is the ratio of the Consumption of fixed capital (as % of GNI) in Niger in 2000 to that in 2004?
Ensure brevity in your answer.  1.71. What is the ratio of the Consumption of fixed capital (as % of GNI) in Low & middle income in 2000 to that in 2005?
Ensure brevity in your answer.  0.94. What is the ratio of the Consumption of fixed capital (as % of GNI) in Belarus in 2000 to that in 2005?
Make the answer very short. 1.48. What is the ratio of the Consumption of fixed capital (as % of GNI) of Niger in 2000 to that in 2005?
Your answer should be compact. 2.46. What is the ratio of the Consumption of fixed capital (as % of GNI) in Low & middle income in 2000 to that in 2006?
Offer a terse response. 0.93. What is the ratio of the Consumption of fixed capital (as % of GNI) of Belarus in 2000 to that in 2006?
Give a very brief answer. 1.59. What is the ratio of the Consumption of fixed capital (as % of GNI) in Niger in 2000 to that in 2006?
Provide a succinct answer. 1.87. What is the ratio of the Consumption of fixed capital (as % of GNI) in Low & middle income in 2001 to that in 2002?
Keep it short and to the point. 0.99. What is the ratio of the Consumption of fixed capital (as % of GNI) of Belarus in 2001 to that in 2002?
Provide a short and direct response. 1.09. What is the ratio of the Consumption of fixed capital (as % of GNI) of Niger in 2001 to that in 2002?
Provide a succinct answer. 1.07. What is the ratio of the Consumption of fixed capital (as % of GNI) of Belarus in 2001 to that in 2003?
Your answer should be very brief. 1.23. What is the ratio of the Consumption of fixed capital (as % of GNI) in Niger in 2001 to that in 2003?
Offer a very short reply. 1.12. What is the ratio of the Consumption of fixed capital (as % of GNI) in Low & middle income in 2001 to that in 2004?
Make the answer very short. 0.99. What is the ratio of the Consumption of fixed capital (as % of GNI) in Belarus in 2001 to that in 2004?
Give a very brief answer. 1.35. What is the ratio of the Consumption of fixed capital (as % of GNI) of Niger in 2001 to that in 2004?
Give a very brief answer. 1.34. What is the ratio of the Consumption of fixed capital (as % of GNI) in Low & middle income in 2001 to that in 2005?
Your answer should be compact. 0.98. What is the ratio of the Consumption of fixed capital (as % of GNI) of Belarus in 2001 to that in 2005?
Your response must be concise. 1.39. What is the ratio of the Consumption of fixed capital (as % of GNI) in Niger in 2001 to that in 2005?
Your response must be concise. 1.93. What is the ratio of the Consumption of fixed capital (as % of GNI) in Low & middle income in 2001 to that in 2006?
Your response must be concise. 0.97. What is the ratio of the Consumption of fixed capital (as % of GNI) of Belarus in 2001 to that in 2006?
Your answer should be compact. 1.5. What is the ratio of the Consumption of fixed capital (as % of GNI) of Niger in 2001 to that in 2006?
Give a very brief answer. 1.47. What is the ratio of the Consumption of fixed capital (as % of GNI) of Low & middle income in 2002 to that in 2003?
Your response must be concise. 1. What is the ratio of the Consumption of fixed capital (as % of GNI) of Belarus in 2002 to that in 2003?
Your answer should be very brief. 1.12. What is the ratio of the Consumption of fixed capital (as % of GNI) in Niger in 2002 to that in 2003?
Provide a succinct answer. 1.05. What is the ratio of the Consumption of fixed capital (as % of GNI) of Belarus in 2002 to that in 2004?
Provide a succinct answer. 1.24. What is the ratio of the Consumption of fixed capital (as % of GNI) in Niger in 2002 to that in 2004?
Offer a terse response. 1.26. What is the ratio of the Consumption of fixed capital (as % of GNI) of Low & middle income in 2002 to that in 2005?
Offer a terse response. 0.99. What is the ratio of the Consumption of fixed capital (as % of GNI) in Belarus in 2002 to that in 2005?
Provide a succinct answer. 1.27. What is the ratio of the Consumption of fixed capital (as % of GNI) of Niger in 2002 to that in 2005?
Provide a short and direct response. 1.81. What is the ratio of the Consumption of fixed capital (as % of GNI) in Low & middle income in 2002 to that in 2006?
Offer a terse response. 0.97. What is the ratio of the Consumption of fixed capital (as % of GNI) in Belarus in 2002 to that in 2006?
Ensure brevity in your answer.  1.37. What is the ratio of the Consumption of fixed capital (as % of GNI) of Niger in 2002 to that in 2006?
Give a very brief answer. 1.38. What is the ratio of the Consumption of fixed capital (as % of GNI) of Belarus in 2003 to that in 2004?
Give a very brief answer. 1.1. What is the ratio of the Consumption of fixed capital (as % of GNI) of Niger in 2003 to that in 2004?
Your response must be concise. 1.2. What is the ratio of the Consumption of fixed capital (as % of GNI) in Low & middle income in 2003 to that in 2005?
Provide a short and direct response. 0.99. What is the ratio of the Consumption of fixed capital (as % of GNI) of Belarus in 2003 to that in 2005?
Make the answer very short. 1.13. What is the ratio of the Consumption of fixed capital (as % of GNI) of Niger in 2003 to that in 2005?
Keep it short and to the point. 1.72. What is the ratio of the Consumption of fixed capital (as % of GNI) in Low & middle income in 2003 to that in 2006?
Give a very brief answer. 0.98. What is the ratio of the Consumption of fixed capital (as % of GNI) of Belarus in 2003 to that in 2006?
Provide a short and direct response. 1.22. What is the ratio of the Consumption of fixed capital (as % of GNI) of Niger in 2003 to that in 2006?
Give a very brief answer. 1.31. What is the ratio of the Consumption of fixed capital (as % of GNI) of Belarus in 2004 to that in 2005?
Provide a succinct answer. 1.03. What is the ratio of the Consumption of fixed capital (as % of GNI) in Niger in 2004 to that in 2005?
Provide a short and direct response. 1.44. What is the ratio of the Consumption of fixed capital (as % of GNI) in Low & middle income in 2004 to that in 2006?
Give a very brief answer. 0.98. What is the ratio of the Consumption of fixed capital (as % of GNI) of Belarus in 2004 to that in 2006?
Offer a very short reply. 1.11. What is the ratio of the Consumption of fixed capital (as % of GNI) in Niger in 2004 to that in 2006?
Give a very brief answer. 1.09. What is the ratio of the Consumption of fixed capital (as % of GNI) of Low & middle income in 2005 to that in 2006?
Make the answer very short. 0.99. What is the ratio of the Consumption of fixed capital (as % of GNI) of Belarus in 2005 to that in 2006?
Make the answer very short. 1.08. What is the ratio of the Consumption of fixed capital (as % of GNI) of Niger in 2005 to that in 2006?
Your answer should be compact. 0.76. What is the difference between the highest and the second highest Consumption of fixed capital (as % of GNI) of Low & middle income?
Offer a very short reply. 0.17. What is the difference between the highest and the second highest Consumption of fixed capital (as % of GNI) in Belarus?
Your answer should be compact. 2.66. What is the difference between the highest and the second highest Consumption of fixed capital (as % of GNI) in Niger?
Provide a short and direct response. 0.6. What is the difference between the highest and the lowest Consumption of fixed capital (as % of GNI) of Low & middle income?
Keep it short and to the point. 0.79. What is the difference between the highest and the lowest Consumption of fixed capital (as % of GNI) in Belarus?
Offer a terse response. 7.46. What is the difference between the highest and the lowest Consumption of fixed capital (as % of GNI) in Niger?
Offer a terse response. 3.63. 